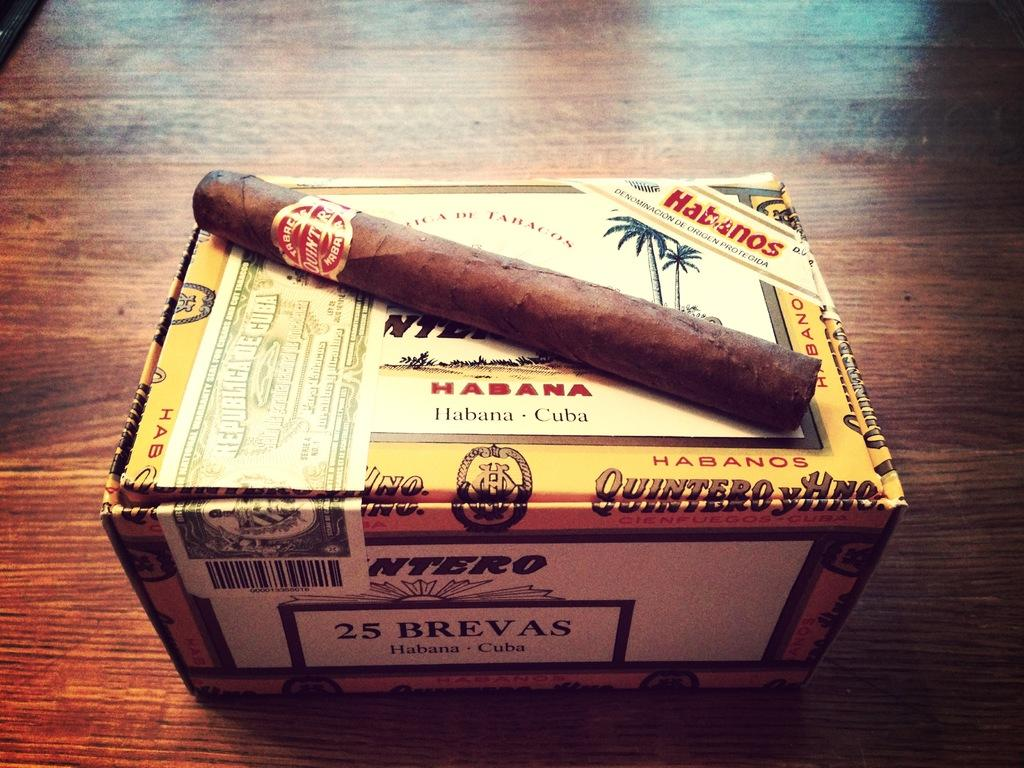<image>
Summarize the visual content of the image. A Habana cigar that is sitting on a cigar box. 